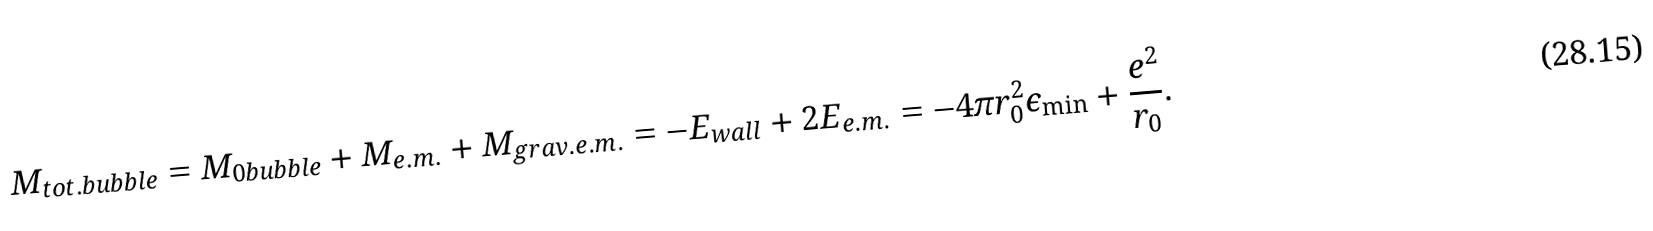<formula> <loc_0><loc_0><loc_500><loc_500>M _ { t o t . b u b b l e } = M _ { 0 b u b b l e } + M _ { e . m . } + M _ { g r a v . e . m . } = - E _ { w a l l } + 2 E _ { e . m . } = - 4 \pi r _ { 0 } ^ { 2 } \epsilon _ { \min } + \frac { e ^ { 2 } } { r _ { 0 } } .</formula> 